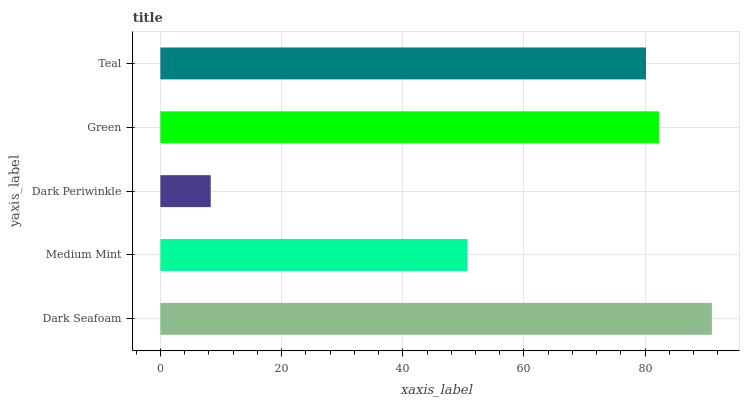Is Dark Periwinkle the minimum?
Answer yes or no. Yes. Is Dark Seafoam the maximum?
Answer yes or no. Yes. Is Medium Mint the minimum?
Answer yes or no. No. Is Medium Mint the maximum?
Answer yes or no. No. Is Dark Seafoam greater than Medium Mint?
Answer yes or no. Yes. Is Medium Mint less than Dark Seafoam?
Answer yes or no. Yes. Is Medium Mint greater than Dark Seafoam?
Answer yes or no. No. Is Dark Seafoam less than Medium Mint?
Answer yes or no. No. Is Teal the high median?
Answer yes or no. Yes. Is Teal the low median?
Answer yes or no. Yes. Is Green the high median?
Answer yes or no. No. Is Medium Mint the low median?
Answer yes or no. No. 